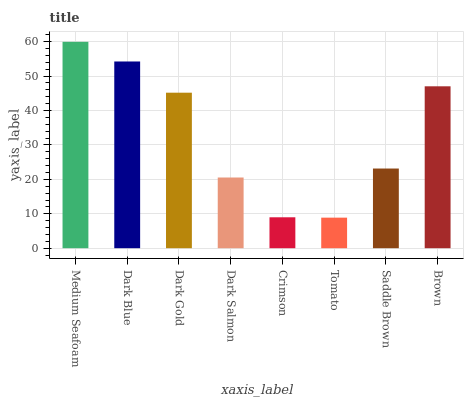Is Tomato the minimum?
Answer yes or no. Yes. Is Medium Seafoam the maximum?
Answer yes or no. Yes. Is Dark Blue the minimum?
Answer yes or no. No. Is Dark Blue the maximum?
Answer yes or no. No. Is Medium Seafoam greater than Dark Blue?
Answer yes or no. Yes. Is Dark Blue less than Medium Seafoam?
Answer yes or no. Yes. Is Dark Blue greater than Medium Seafoam?
Answer yes or no. No. Is Medium Seafoam less than Dark Blue?
Answer yes or no. No. Is Dark Gold the high median?
Answer yes or no. Yes. Is Saddle Brown the low median?
Answer yes or no. Yes. Is Dark Salmon the high median?
Answer yes or no. No. Is Medium Seafoam the low median?
Answer yes or no. No. 